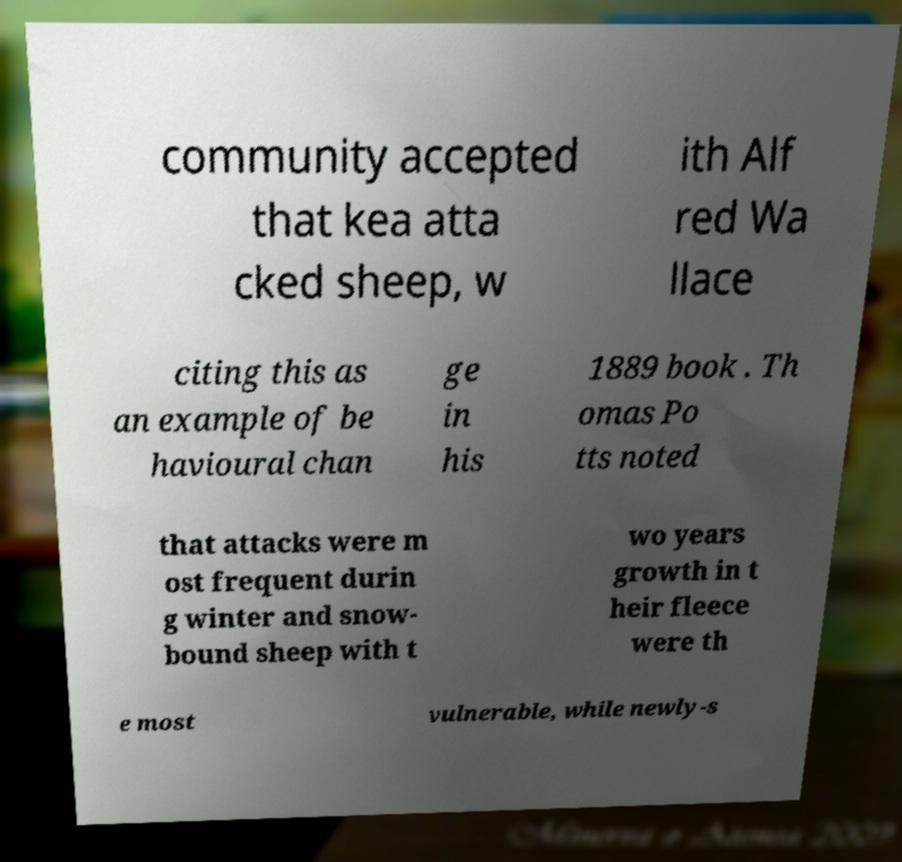Can you accurately transcribe the text from the provided image for me? community accepted that kea atta cked sheep, w ith Alf red Wa llace citing this as an example of be havioural chan ge in his 1889 book . Th omas Po tts noted that attacks were m ost frequent durin g winter and snow- bound sheep with t wo years growth in t heir fleece were th e most vulnerable, while newly-s 